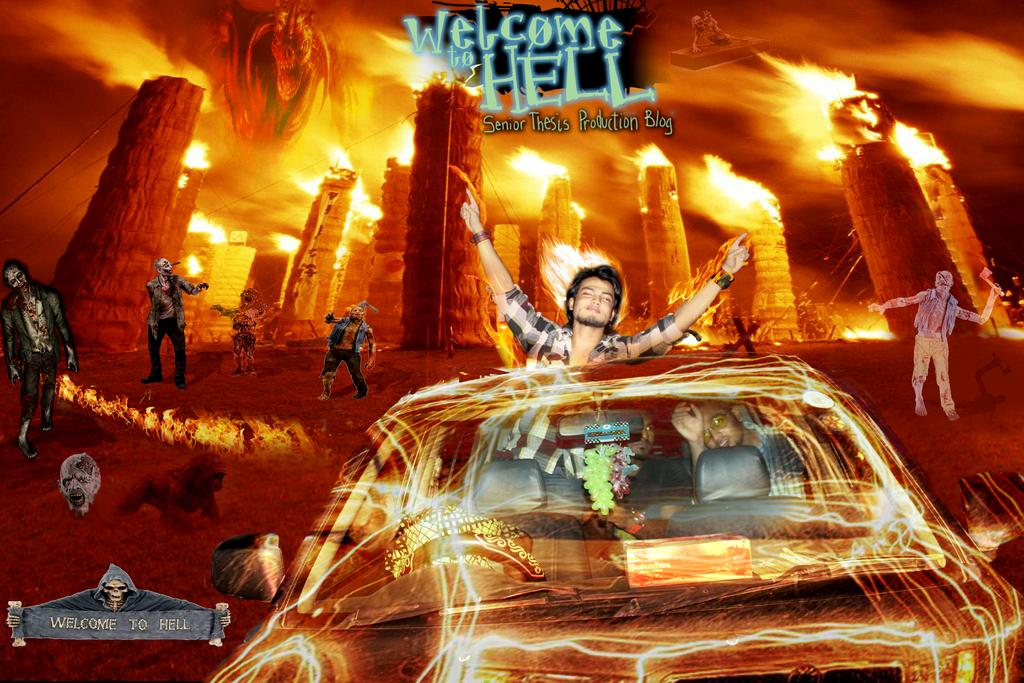<image>
Share a concise interpretation of the image provided. A work of art is caption with the phrase Welcome to Hell 